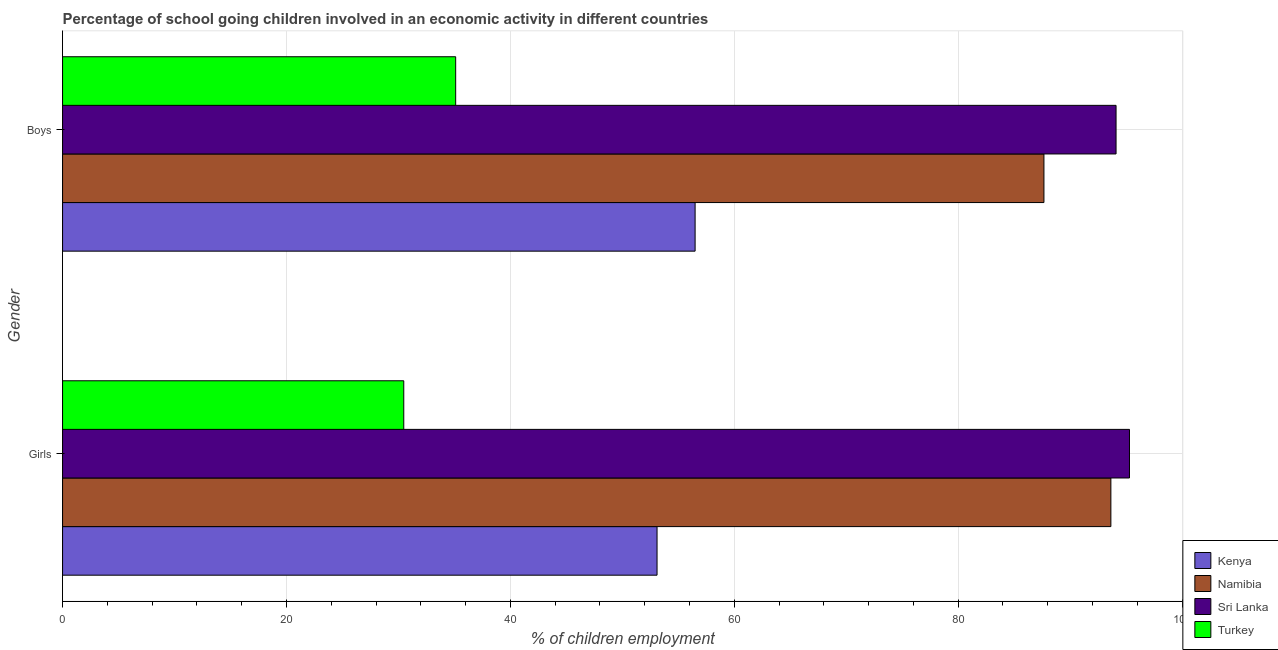How many different coloured bars are there?
Your answer should be compact. 4. How many groups of bars are there?
Keep it short and to the point. 2. Are the number of bars on each tick of the Y-axis equal?
Give a very brief answer. Yes. How many bars are there on the 2nd tick from the top?
Your answer should be very brief. 4. How many bars are there on the 1st tick from the bottom?
Provide a short and direct response. 4. What is the label of the 2nd group of bars from the top?
Your answer should be very brief. Girls. What is the percentage of school going girls in Sri Lanka?
Your answer should be very brief. 95.3. Across all countries, what is the maximum percentage of school going boys?
Keep it short and to the point. 94.1. Across all countries, what is the minimum percentage of school going girls?
Offer a terse response. 30.48. In which country was the percentage of school going girls maximum?
Ensure brevity in your answer.  Sri Lanka. In which country was the percentage of school going girls minimum?
Offer a terse response. Turkey. What is the total percentage of school going boys in the graph?
Keep it short and to the point. 273.37. What is the difference between the percentage of school going boys in Sri Lanka and that in Kenya?
Your answer should be compact. 37.6. What is the difference between the percentage of school going boys in Namibia and the percentage of school going girls in Sri Lanka?
Keep it short and to the point. -7.64. What is the average percentage of school going girls per country?
Give a very brief answer. 68.13. What is the difference between the percentage of school going girls and percentage of school going boys in Turkey?
Give a very brief answer. -4.64. What is the ratio of the percentage of school going boys in Kenya to that in Turkey?
Your answer should be compact. 1.61. Is the percentage of school going boys in Namibia less than that in Sri Lanka?
Provide a succinct answer. Yes. What does the 4th bar from the top in Boys represents?
Keep it short and to the point. Kenya. What does the 3rd bar from the bottom in Boys represents?
Offer a very short reply. Sri Lanka. How many bars are there?
Provide a short and direct response. 8. Are all the bars in the graph horizontal?
Offer a very short reply. Yes. What is the difference between two consecutive major ticks on the X-axis?
Give a very brief answer. 20. Are the values on the major ticks of X-axis written in scientific E-notation?
Keep it short and to the point. No. Does the graph contain grids?
Give a very brief answer. Yes. Where does the legend appear in the graph?
Offer a very short reply. Bottom right. What is the title of the graph?
Offer a very short reply. Percentage of school going children involved in an economic activity in different countries. What is the label or title of the X-axis?
Keep it short and to the point. % of children employment. What is the % of children employment in Kenya in Girls?
Offer a very short reply. 53.1. What is the % of children employment in Namibia in Girls?
Offer a very short reply. 93.64. What is the % of children employment in Sri Lanka in Girls?
Offer a terse response. 95.3. What is the % of children employment of Turkey in Girls?
Offer a terse response. 30.48. What is the % of children employment in Kenya in Boys?
Offer a terse response. 56.5. What is the % of children employment of Namibia in Boys?
Offer a very short reply. 87.66. What is the % of children employment of Sri Lanka in Boys?
Your answer should be very brief. 94.1. What is the % of children employment in Turkey in Boys?
Provide a short and direct response. 35.11. Across all Gender, what is the maximum % of children employment in Kenya?
Your response must be concise. 56.5. Across all Gender, what is the maximum % of children employment in Namibia?
Offer a very short reply. 93.64. Across all Gender, what is the maximum % of children employment of Sri Lanka?
Provide a short and direct response. 95.3. Across all Gender, what is the maximum % of children employment in Turkey?
Your answer should be compact. 35.11. Across all Gender, what is the minimum % of children employment in Kenya?
Give a very brief answer. 53.1. Across all Gender, what is the minimum % of children employment of Namibia?
Offer a terse response. 87.66. Across all Gender, what is the minimum % of children employment in Sri Lanka?
Ensure brevity in your answer.  94.1. Across all Gender, what is the minimum % of children employment in Turkey?
Provide a succinct answer. 30.48. What is the total % of children employment of Kenya in the graph?
Provide a short and direct response. 109.6. What is the total % of children employment in Namibia in the graph?
Your answer should be very brief. 181.29. What is the total % of children employment of Sri Lanka in the graph?
Keep it short and to the point. 189.4. What is the total % of children employment of Turkey in the graph?
Offer a very short reply. 65.59. What is the difference between the % of children employment in Kenya in Girls and that in Boys?
Provide a succinct answer. -3.4. What is the difference between the % of children employment in Namibia in Girls and that in Boys?
Ensure brevity in your answer.  5.98. What is the difference between the % of children employment in Turkey in Girls and that in Boys?
Your response must be concise. -4.64. What is the difference between the % of children employment in Kenya in Girls and the % of children employment in Namibia in Boys?
Ensure brevity in your answer.  -34.56. What is the difference between the % of children employment in Kenya in Girls and the % of children employment in Sri Lanka in Boys?
Ensure brevity in your answer.  -41. What is the difference between the % of children employment of Kenya in Girls and the % of children employment of Turkey in Boys?
Offer a very short reply. 17.99. What is the difference between the % of children employment in Namibia in Girls and the % of children employment in Sri Lanka in Boys?
Your answer should be compact. -0.46. What is the difference between the % of children employment in Namibia in Girls and the % of children employment in Turkey in Boys?
Provide a succinct answer. 58.52. What is the difference between the % of children employment in Sri Lanka in Girls and the % of children employment in Turkey in Boys?
Provide a succinct answer. 60.19. What is the average % of children employment in Kenya per Gender?
Your answer should be very brief. 54.8. What is the average % of children employment of Namibia per Gender?
Your answer should be very brief. 90.65. What is the average % of children employment of Sri Lanka per Gender?
Provide a succinct answer. 94.7. What is the average % of children employment of Turkey per Gender?
Make the answer very short. 32.79. What is the difference between the % of children employment of Kenya and % of children employment of Namibia in Girls?
Keep it short and to the point. -40.54. What is the difference between the % of children employment of Kenya and % of children employment of Sri Lanka in Girls?
Your answer should be very brief. -42.2. What is the difference between the % of children employment in Kenya and % of children employment in Turkey in Girls?
Give a very brief answer. 22.62. What is the difference between the % of children employment of Namibia and % of children employment of Sri Lanka in Girls?
Make the answer very short. -1.66. What is the difference between the % of children employment in Namibia and % of children employment in Turkey in Girls?
Give a very brief answer. 63.16. What is the difference between the % of children employment of Sri Lanka and % of children employment of Turkey in Girls?
Give a very brief answer. 64.82. What is the difference between the % of children employment in Kenya and % of children employment in Namibia in Boys?
Give a very brief answer. -31.16. What is the difference between the % of children employment of Kenya and % of children employment of Sri Lanka in Boys?
Keep it short and to the point. -37.6. What is the difference between the % of children employment in Kenya and % of children employment in Turkey in Boys?
Offer a very short reply. 21.39. What is the difference between the % of children employment in Namibia and % of children employment in Sri Lanka in Boys?
Your answer should be compact. -6.44. What is the difference between the % of children employment of Namibia and % of children employment of Turkey in Boys?
Ensure brevity in your answer.  52.54. What is the difference between the % of children employment in Sri Lanka and % of children employment in Turkey in Boys?
Your answer should be compact. 58.99. What is the ratio of the % of children employment of Kenya in Girls to that in Boys?
Offer a terse response. 0.94. What is the ratio of the % of children employment of Namibia in Girls to that in Boys?
Offer a terse response. 1.07. What is the ratio of the % of children employment in Sri Lanka in Girls to that in Boys?
Offer a terse response. 1.01. What is the ratio of the % of children employment of Turkey in Girls to that in Boys?
Offer a very short reply. 0.87. What is the difference between the highest and the second highest % of children employment of Kenya?
Ensure brevity in your answer.  3.4. What is the difference between the highest and the second highest % of children employment of Namibia?
Offer a very short reply. 5.98. What is the difference between the highest and the second highest % of children employment in Sri Lanka?
Keep it short and to the point. 1.2. What is the difference between the highest and the second highest % of children employment in Turkey?
Provide a succinct answer. 4.64. What is the difference between the highest and the lowest % of children employment in Namibia?
Your answer should be very brief. 5.98. What is the difference between the highest and the lowest % of children employment of Turkey?
Offer a terse response. 4.64. 